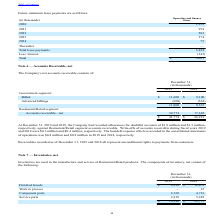According to Par Technology's financial document, Where are Inventories used? in the manufacture and service of Restaurant/Retail products.. The document states: "Inventories are used in the manufacture and service of Restaurant/Retail products. The components of inventory, net consist of the following:..." Also, How much was the inventory write-downs at December 31, 2019 and 2018 respectively? The document shows two values: $9.6 million and $9.8 million. Also, What is the value of Finished Goods in 2019 and 2018 respectively? The document shows two values: $8,320 and $12,472 (in thousands). From the document: "Finished Goods $ 8,320 $ 12,472 Finished Goods $ 8,320 $ 12,472..." Also, can you calculate: What is the change in Finished Goods between December 31, 2018 and 2019? Based on the calculation: 8,320-12,472, the result is -4152 (in thousands). This is based on the information: "Finished Goods $ 8,320 $ 12,472 Finished Goods $ 8,320 $ 12,472..." The key data points involved are: 12,472, 8,320. Also, can you calculate: What is the change in Component parts between December 31, 2018 and 2019? Based on the calculation: 6,768-4,716, the result is 2052 (in thousands). This is based on the information: "Component parts 6,768 4,716 Component parts 6,768 4,716..." The key data points involved are: 4,716, 6,768. Also, can you calculate: What is the average Finished Goods for December 31, 2018 and 2019? To answer this question, I need to perform calculations using the financial data. The calculation is: (8,320+12,472) / 2, which equals 10396 (in thousands). This is based on the information: "Finished Goods $ 8,320 $ 12,472 Finished Goods $ 8,320 $ 12,472..." The key data points involved are: 12,472, 8,320. 